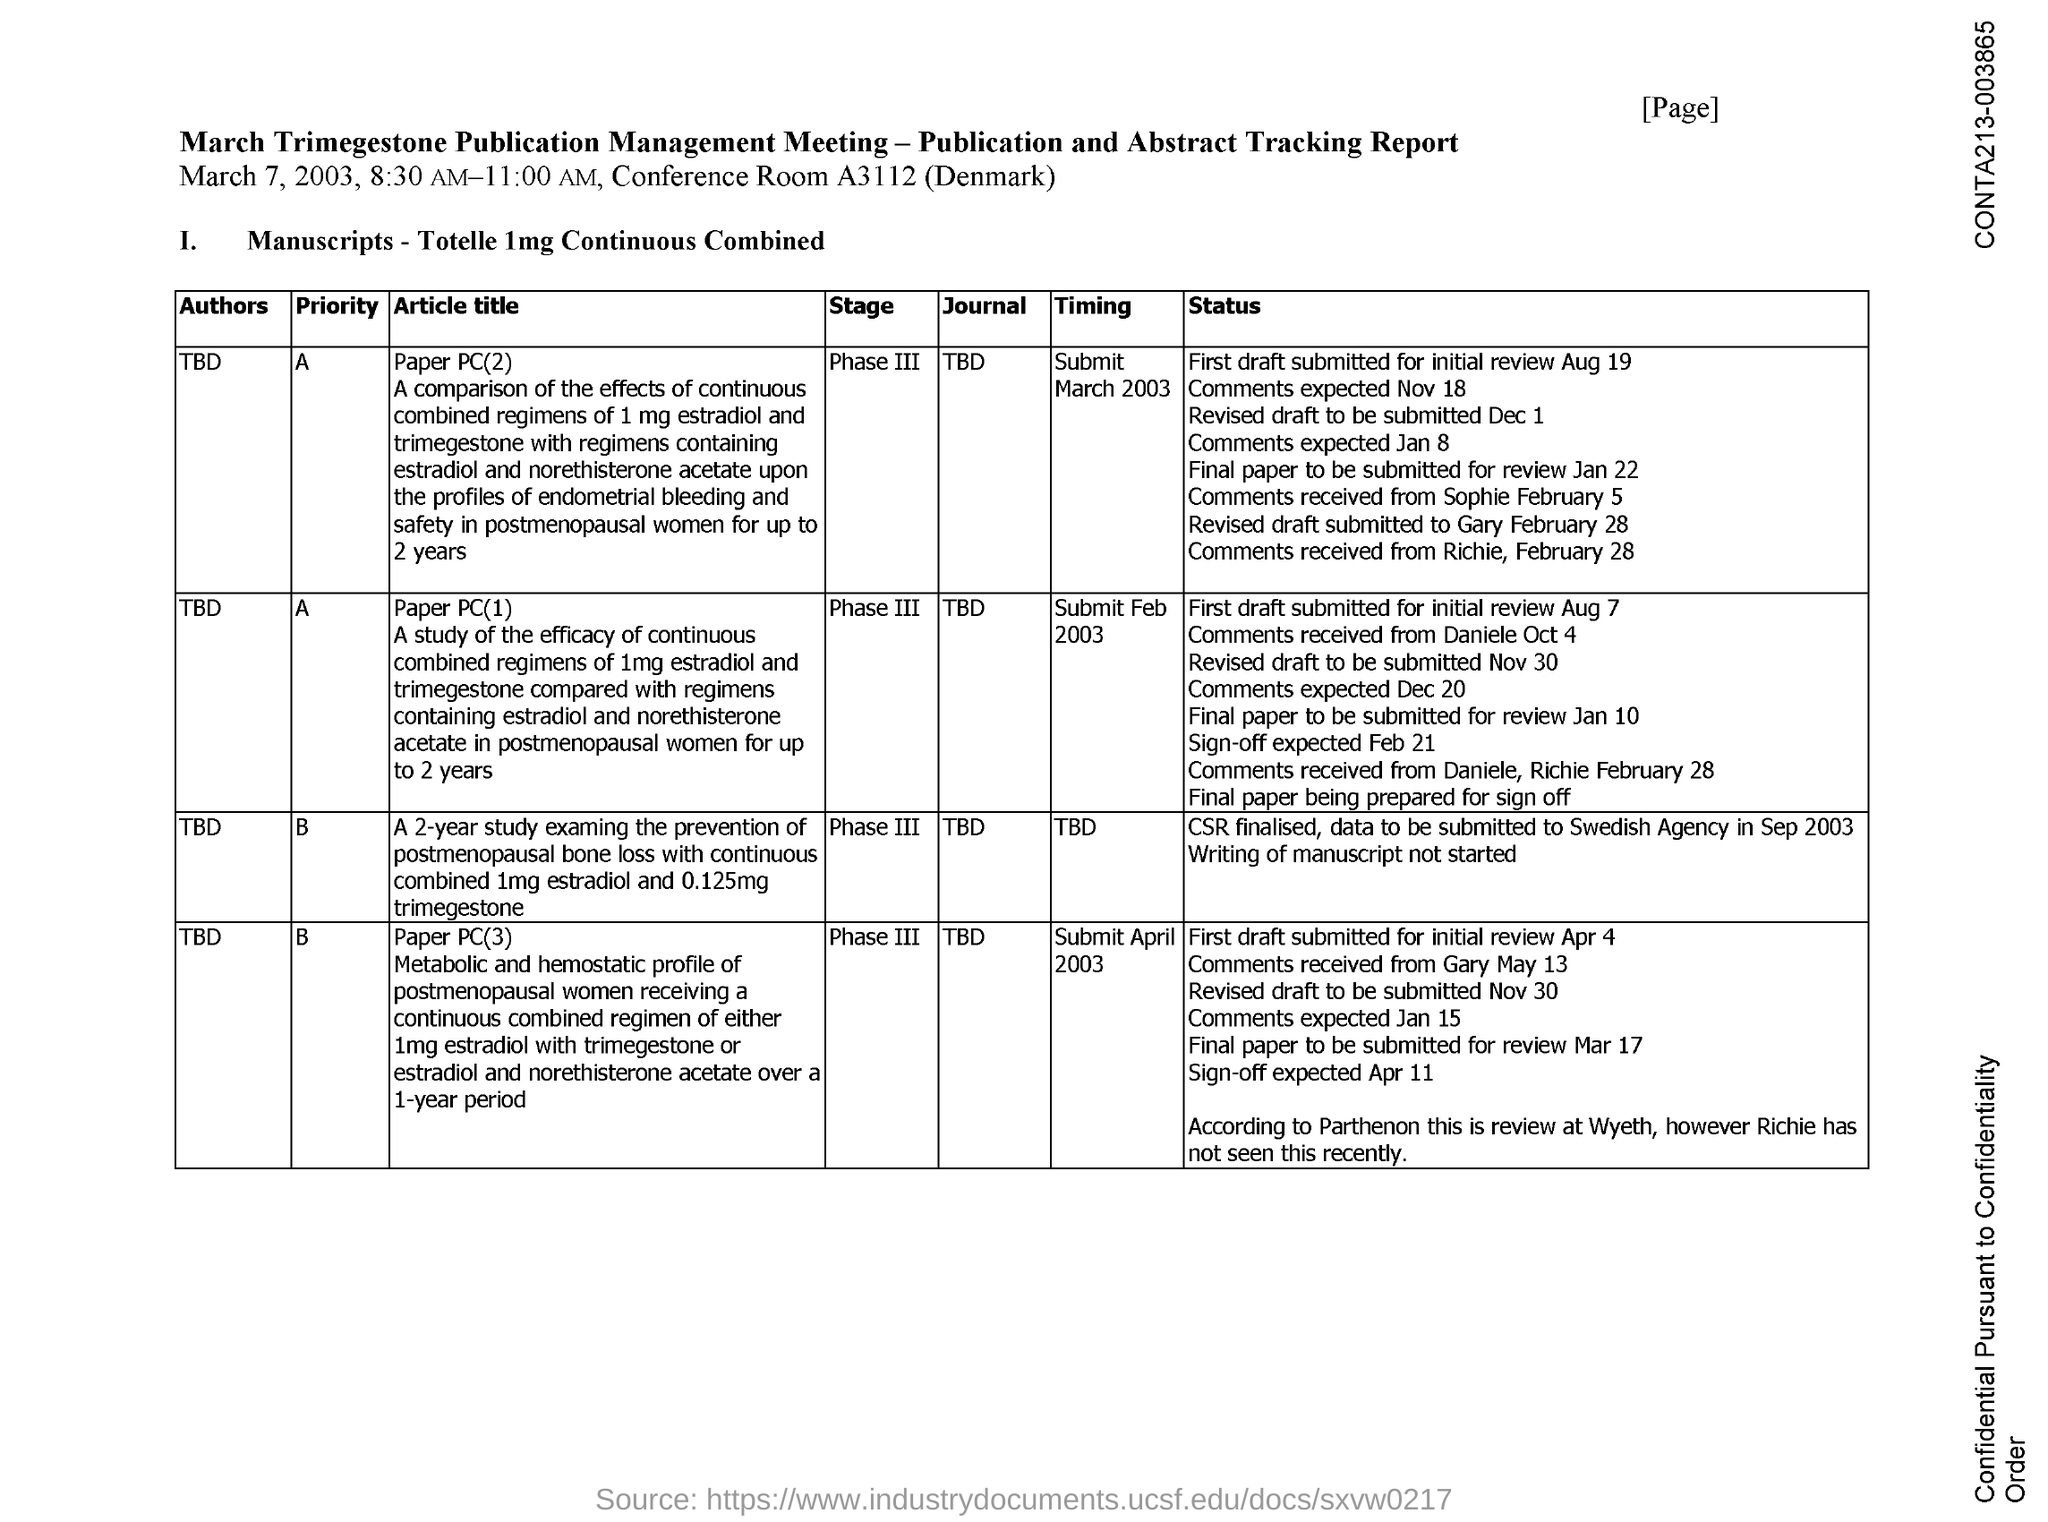Point out several critical features in this image. The conference room number is A3112. 